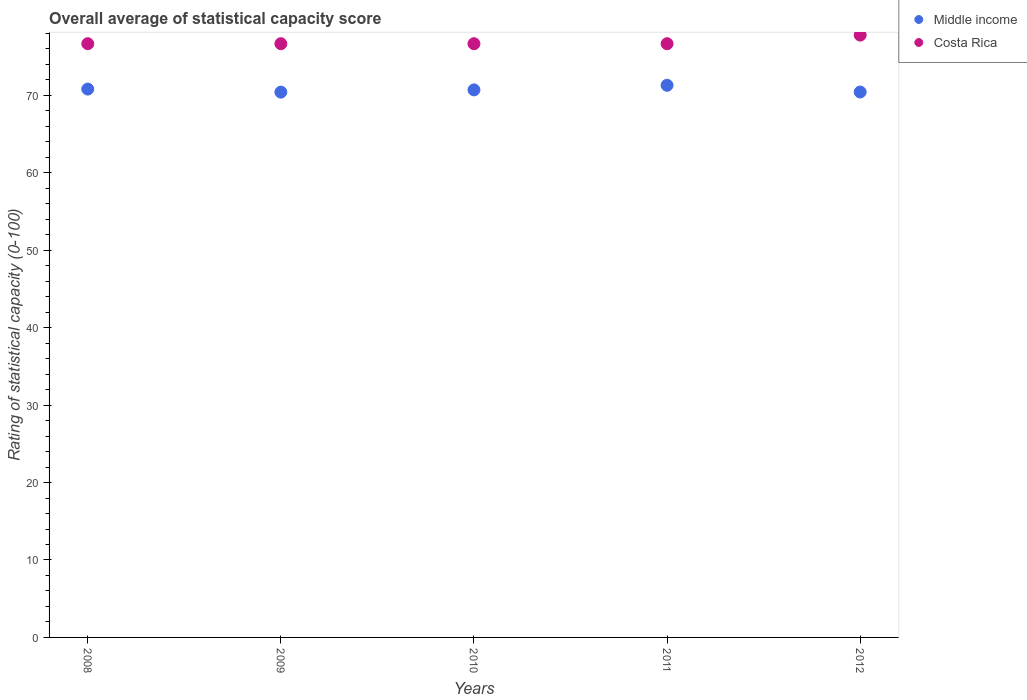How many different coloured dotlines are there?
Keep it short and to the point. 2. Is the number of dotlines equal to the number of legend labels?
Offer a very short reply. Yes. What is the rating of statistical capacity in Middle income in 2008?
Make the answer very short. 70.81. Across all years, what is the maximum rating of statistical capacity in Middle income?
Your response must be concise. 71.3. Across all years, what is the minimum rating of statistical capacity in Costa Rica?
Give a very brief answer. 76.67. In which year was the rating of statistical capacity in Costa Rica maximum?
Provide a succinct answer. 2012. What is the total rating of statistical capacity in Middle income in the graph?
Your response must be concise. 353.65. What is the difference between the rating of statistical capacity in Costa Rica in 2008 and that in 2011?
Provide a succinct answer. 0. What is the difference between the rating of statistical capacity in Costa Rica in 2012 and the rating of statistical capacity in Middle income in 2009?
Your answer should be compact. 7.36. What is the average rating of statistical capacity in Middle income per year?
Offer a terse response. 70.73. In the year 2009, what is the difference between the rating of statistical capacity in Costa Rica and rating of statistical capacity in Middle income?
Your answer should be very brief. 6.25. What is the ratio of the rating of statistical capacity in Middle income in 2009 to that in 2010?
Provide a succinct answer. 1. Is the difference between the rating of statistical capacity in Costa Rica in 2009 and 2012 greater than the difference between the rating of statistical capacity in Middle income in 2009 and 2012?
Your answer should be compact. No. What is the difference between the highest and the second highest rating of statistical capacity in Costa Rica?
Offer a terse response. 1.11. What is the difference between the highest and the lowest rating of statistical capacity in Costa Rica?
Give a very brief answer. 1.11. Is the sum of the rating of statistical capacity in Middle income in 2009 and 2012 greater than the maximum rating of statistical capacity in Costa Rica across all years?
Provide a short and direct response. Yes. Is the rating of statistical capacity in Middle income strictly less than the rating of statistical capacity in Costa Rica over the years?
Give a very brief answer. Yes. Does the graph contain any zero values?
Give a very brief answer. No. Does the graph contain grids?
Offer a very short reply. No. Where does the legend appear in the graph?
Your answer should be very brief. Top right. What is the title of the graph?
Your answer should be compact. Overall average of statistical capacity score. What is the label or title of the Y-axis?
Ensure brevity in your answer.  Rating of statistical capacity (0-100). What is the Rating of statistical capacity (0-100) in Middle income in 2008?
Your answer should be compact. 70.81. What is the Rating of statistical capacity (0-100) of Costa Rica in 2008?
Provide a short and direct response. 76.67. What is the Rating of statistical capacity (0-100) of Middle income in 2009?
Give a very brief answer. 70.41. What is the Rating of statistical capacity (0-100) in Costa Rica in 2009?
Your answer should be very brief. 76.67. What is the Rating of statistical capacity (0-100) of Middle income in 2010?
Ensure brevity in your answer.  70.71. What is the Rating of statistical capacity (0-100) of Costa Rica in 2010?
Offer a very short reply. 76.67. What is the Rating of statistical capacity (0-100) in Middle income in 2011?
Your answer should be very brief. 71.3. What is the Rating of statistical capacity (0-100) of Costa Rica in 2011?
Offer a terse response. 76.67. What is the Rating of statistical capacity (0-100) of Middle income in 2012?
Your response must be concise. 70.43. What is the Rating of statistical capacity (0-100) in Costa Rica in 2012?
Your response must be concise. 77.78. Across all years, what is the maximum Rating of statistical capacity (0-100) of Middle income?
Your answer should be compact. 71.3. Across all years, what is the maximum Rating of statistical capacity (0-100) in Costa Rica?
Offer a very short reply. 77.78. Across all years, what is the minimum Rating of statistical capacity (0-100) of Middle income?
Provide a short and direct response. 70.41. Across all years, what is the minimum Rating of statistical capacity (0-100) of Costa Rica?
Give a very brief answer. 76.67. What is the total Rating of statistical capacity (0-100) in Middle income in the graph?
Offer a terse response. 353.65. What is the total Rating of statistical capacity (0-100) in Costa Rica in the graph?
Keep it short and to the point. 384.44. What is the difference between the Rating of statistical capacity (0-100) in Middle income in 2008 and that in 2009?
Your response must be concise. 0.4. What is the difference between the Rating of statistical capacity (0-100) of Costa Rica in 2008 and that in 2009?
Provide a short and direct response. 0. What is the difference between the Rating of statistical capacity (0-100) of Middle income in 2008 and that in 2010?
Offer a terse response. 0.1. What is the difference between the Rating of statistical capacity (0-100) in Costa Rica in 2008 and that in 2010?
Provide a succinct answer. 0. What is the difference between the Rating of statistical capacity (0-100) of Middle income in 2008 and that in 2011?
Ensure brevity in your answer.  -0.49. What is the difference between the Rating of statistical capacity (0-100) of Middle income in 2008 and that in 2012?
Your answer should be very brief. 0.38. What is the difference between the Rating of statistical capacity (0-100) in Costa Rica in 2008 and that in 2012?
Ensure brevity in your answer.  -1.11. What is the difference between the Rating of statistical capacity (0-100) in Middle income in 2009 and that in 2010?
Ensure brevity in your answer.  -0.29. What is the difference between the Rating of statistical capacity (0-100) of Costa Rica in 2009 and that in 2010?
Offer a terse response. 0. What is the difference between the Rating of statistical capacity (0-100) in Middle income in 2009 and that in 2011?
Your answer should be compact. -0.88. What is the difference between the Rating of statistical capacity (0-100) of Costa Rica in 2009 and that in 2011?
Give a very brief answer. 0. What is the difference between the Rating of statistical capacity (0-100) of Middle income in 2009 and that in 2012?
Ensure brevity in your answer.  -0.01. What is the difference between the Rating of statistical capacity (0-100) of Costa Rica in 2009 and that in 2012?
Ensure brevity in your answer.  -1.11. What is the difference between the Rating of statistical capacity (0-100) in Middle income in 2010 and that in 2011?
Keep it short and to the point. -0.59. What is the difference between the Rating of statistical capacity (0-100) of Middle income in 2010 and that in 2012?
Offer a very short reply. 0.28. What is the difference between the Rating of statistical capacity (0-100) of Costa Rica in 2010 and that in 2012?
Your answer should be very brief. -1.11. What is the difference between the Rating of statistical capacity (0-100) of Middle income in 2011 and that in 2012?
Offer a very short reply. 0.87. What is the difference between the Rating of statistical capacity (0-100) in Costa Rica in 2011 and that in 2012?
Make the answer very short. -1.11. What is the difference between the Rating of statistical capacity (0-100) in Middle income in 2008 and the Rating of statistical capacity (0-100) in Costa Rica in 2009?
Ensure brevity in your answer.  -5.86. What is the difference between the Rating of statistical capacity (0-100) of Middle income in 2008 and the Rating of statistical capacity (0-100) of Costa Rica in 2010?
Your answer should be very brief. -5.86. What is the difference between the Rating of statistical capacity (0-100) of Middle income in 2008 and the Rating of statistical capacity (0-100) of Costa Rica in 2011?
Keep it short and to the point. -5.86. What is the difference between the Rating of statistical capacity (0-100) in Middle income in 2008 and the Rating of statistical capacity (0-100) in Costa Rica in 2012?
Your answer should be compact. -6.97. What is the difference between the Rating of statistical capacity (0-100) of Middle income in 2009 and the Rating of statistical capacity (0-100) of Costa Rica in 2010?
Provide a short and direct response. -6.25. What is the difference between the Rating of statistical capacity (0-100) of Middle income in 2009 and the Rating of statistical capacity (0-100) of Costa Rica in 2011?
Offer a very short reply. -6.25. What is the difference between the Rating of statistical capacity (0-100) of Middle income in 2009 and the Rating of statistical capacity (0-100) of Costa Rica in 2012?
Your answer should be compact. -7.36. What is the difference between the Rating of statistical capacity (0-100) in Middle income in 2010 and the Rating of statistical capacity (0-100) in Costa Rica in 2011?
Provide a short and direct response. -5.96. What is the difference between the Rating of statistical capacity (0-100) of Middle income in 2010 and the Rating of statistical capacity (0-100) of Costa Rica in 2012?
Give a very brief answer. -7.07. What is the difference between the Rating of statistical capacity (0-100) in Middle income in 2011 and the Rating of statistical capacity (0-100) in Costa Rica in 2012?
Ensure brevity in your answer.  -6.48. What is the average Rating of statistical capacity (0-100) of Middle income per year?
Make the answer very short. 70.73. What is the average Rating of statistical capacity (0-100) in Costa Rica per year?
Ensure brevity in your answer.  76.89. In the year 2008, what is the difference between the Rating of statistical capacity (0-100) of Middle income and Rating of statistical capacity (0-100) of Costa Rica?
Your answer should be compact. -5.86. In the year 2009, what is the difference between the Rating of statistical capacity (0-100) in Middle income and Rating of statistical capacity (0-100) in Costa Rica?
Offer a very short reply. -6.25. In the year 2010, what is the difference between the Rating of statistical capacity (0-100) of Middle income and Rating of statistical capacity (0-100) of Costa Rica?
Your response must be concise. -5.96. In the year 2011, what is the difference between the Rating of statistical capacity (0-100) in Middle income and Rating of statistical capacity (0-100) in Costa Rica?
Provide a succinct answer. -5.37. In the year 2012, what is the difference between the Rating of statistical capacity (0-100) of Middle income and Rating of statistical capacity (0-100) of Costa Rica?
Give a very brief answer. -7.35. What is the ratio of the Rating of statistical capacity (0-100) in Middle income in 2008 to that in 2009?
Your answer should be very brief. 1.01. What is the ratio of the Rating of statistical capacity (0-100) in Middle income in 2008 to that in 2010?
Your answer should be compact. 1. What is the ratio of the Rating of statistical capacity (0-100) of Costa Rica in 2008 to that in 2010?
Your answer should be very brief. 1. What is the ratio of the Rating of statistical capacity (0-100) in Middle income in 2008 to that in 2012?
Offer a very short reply. 1.01. What is the ratio of the Rating of statistical capacity (0-100) of Costa Rica in 2008 to that in 2012?
Offer a very short reply. 0.99. What is the ratio of the Rating of statistical capacity (0-100) in Middle income in 2009 to that in 2010?
Make the answer very short. 1. What is the ratio of the Rating of statistical capacity (0-100) in Costa Rica in 2009 to that in 2010?
Offer a very short reply. 1. What is the ratio of the Rating of statistical capacity (0-100) in Middle income in 2009 to that in 2011?
Your answer should be very brief. 0.99. What is the ratio of the Rating of statistical capacity (0-100) of Costa Rica in 2009 to that in 2011?
Provide a succinct answer. 1. What is the ratio of the Rating of statistical capacity (0-100) in Costa Rica in 2009 to that in 2012?
Your answer should be very brief. 0.99. What is the ratio of the Rating of statistical capacity (0-100) of Costa Rica in 2010 to that in 2011?
Your answer should be compact. 1. What is the ratio of the Rating of statistical capacity (0-100) in Costa Rica in 2010 to that in 2012?
Your answer should be very brief. 0.99. What is the ratio of the Rating of statistical capacity (0-100) in Middle income in 2011 to that in 2012?
Ensure brevity in your answer.  1.01. What is the ratio of the Rating of statistical capacity (0-100) in Costa Rica in 2011 to that in 2012?
Your response must be concise. 0.99. What is the difference between the highest and the second highest Rating of statistical capacity (0-100) in Middle income?
Offer a terse response. 0.49. What is the difference between the highest and the lowest Rating of statistical capacity (0-100) in Middle income?
Make the answer very short. 0.88. 